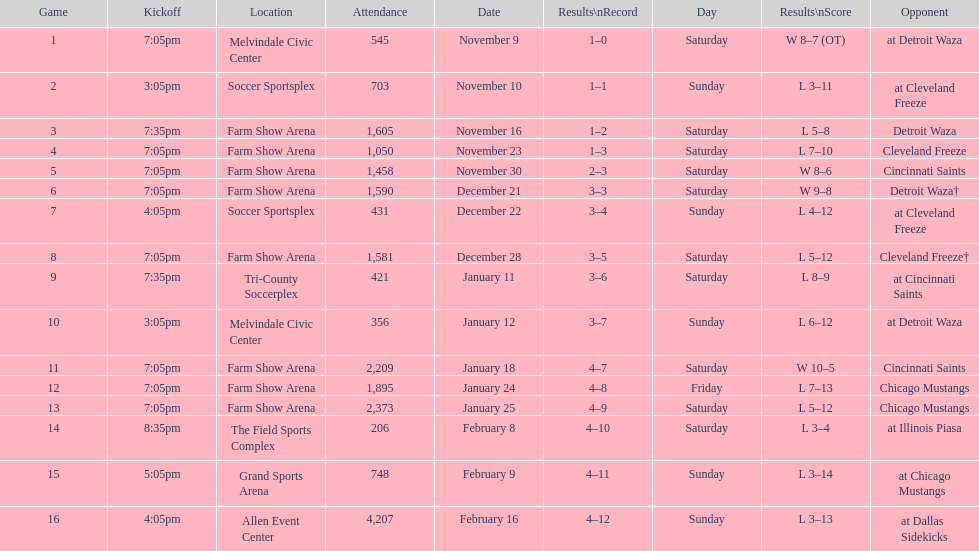How many wins did the harrisburg heat have when they scored at least eight goals in a game? 4. 